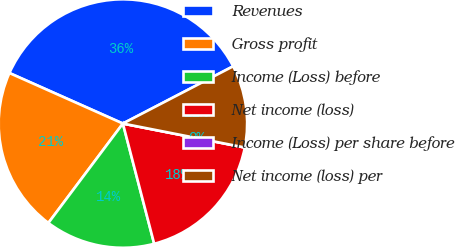<chart> <loc_0><loc_0><loc_500><loc_500><pie_chart><fcel>Revenues<fcel>Gross profit<fcel>Income (Loss) before<fcel>Net income (loss)<fcel>Income (Loss) per share before<fcel>Net income (loss) per<nl><fcel>35.71%<fcel>21.43%<fcel>14.29%<fcel>17.86%<fcel>0.0%<fcel>10.71%<nl></chart> 